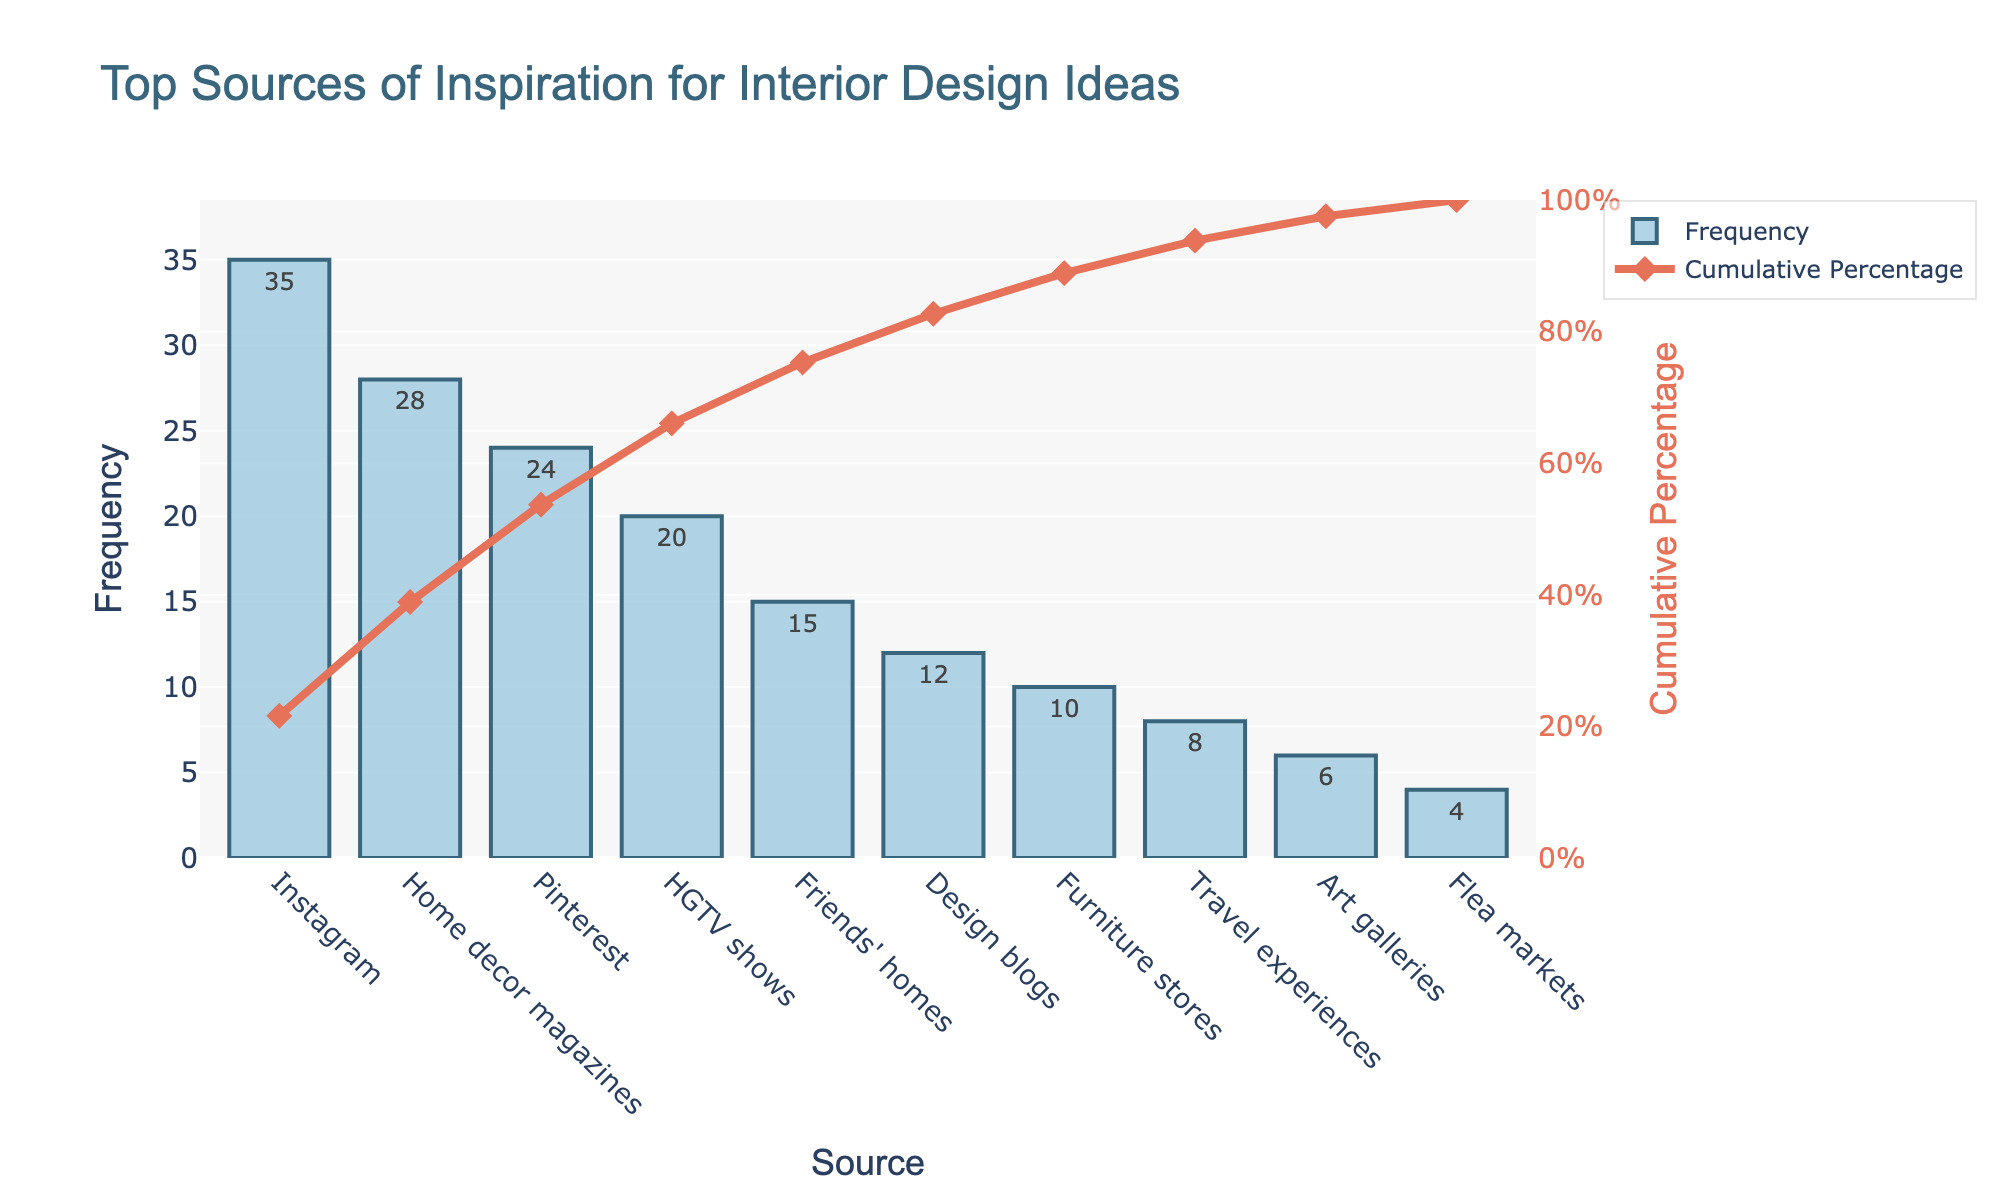What is the most frequently used source of inspiration for interior design ideas? The Pareto chart shows that the bar corresponding to Instagram has the highest frequency, indicating it is the most frequently used source.
Answer: Instagram What is the title of the chart? The title of the chart is displayed at the top, which reads "Top Sources of Inspiration for Interior Design Ideas."
Answer: Top Sources of Inspiration for Interior Design Ideas How many sources have a frequency of more than 20? By inspecting the bars, Instagram, Home decor magazines, Pinterest, and HGTV shows have frequencies greater than 20.
Answer: 4 What is the cumulative percentage when you include Friends' homes as sources of inspiration? The cumulative percentage up to Friends' homes is the sum of the percentages of Instagram, Home decor magazines, Pinterest, HGTV shows, and Friends' homes. With Friends' homes adding up 15%, the cumulative percentage shown on the line chart just above it is approximately 79%.
Answer: 79% Which sources combined contribute to a cumulative percentage of around 77%? By following the cumulative percentage line, Home decor magazines, Pinterest, and HGTV shows combine to give close to a 77% cumulative percentage.
Answer: Instagram, Home decor magazines, Pinterest, HGTV shows Which source has the lowest frequency of inspiration? The shortest bar represents Flea markets with a frequency of 4.
Answer: Flea markets What is the range of the y-axis representing frequency? The y-axis displaying frequency ranges from 0 to approximately 38, considering the highest value is slightly above 35.
Answer: 0 to 38 Which sources have a frequency less than 10 but more than 0? By inspecting the bars, Travel experiences, Art galleries, and Flea markets all have frequencies less than 10 but more than 0.
Answer: Travel experiences, Art galleries, Flea markets Is Pinterest more frequently used than HGTV shows for design inspiration? The bar representing Pinterest is taller than the bar representing HGTV shows, indicating Pinterest is used more frequently.
Answer: Yes 